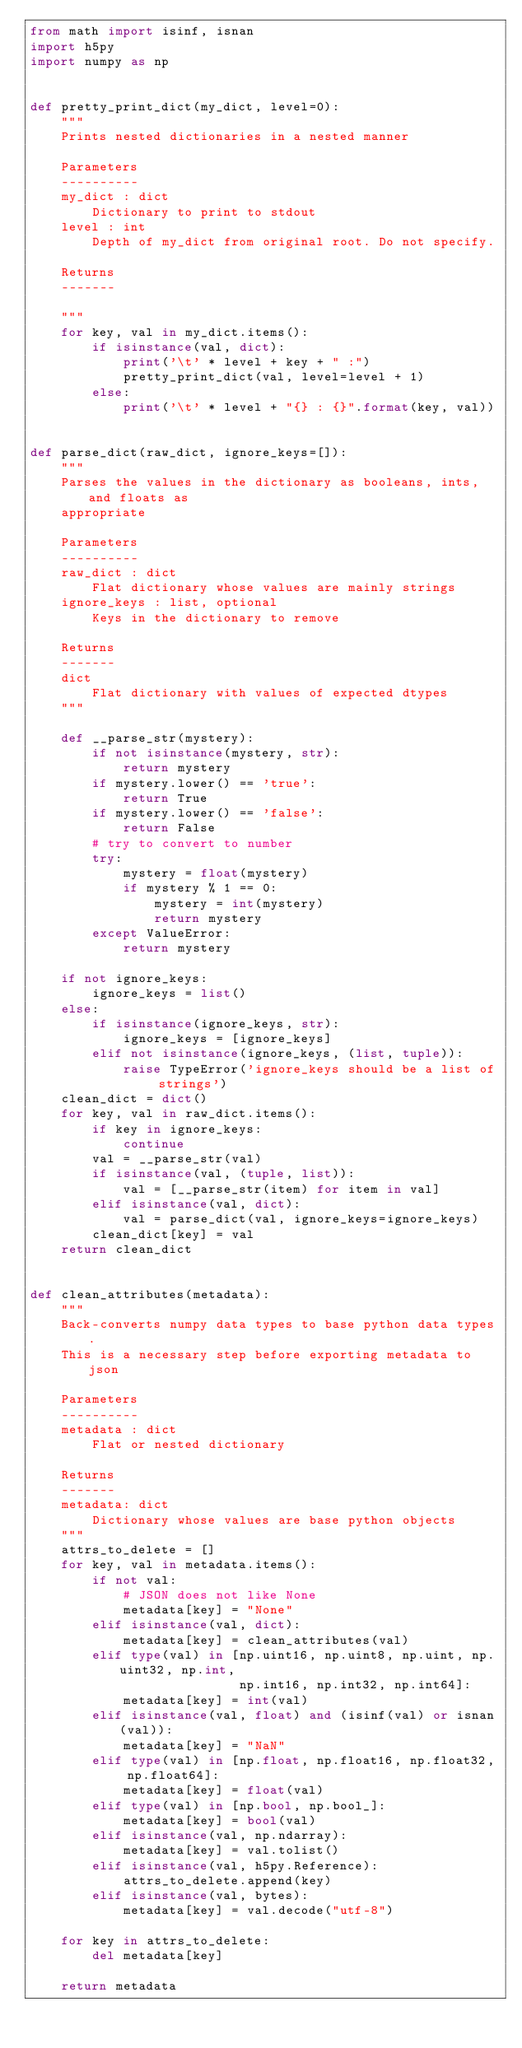<code> <loc_0><loc_0><loc_500><loc_500><_Python_>from math import isinf, isnan
import h5py
import numpy as np


def pretty_print_dict(my_dict, level=0):
    """
    Prints nested dictionaries in a nested manner

    Parameters
    ----------
    my_dict : dict
        Dictionary to print to stdout
    level : int
        Depth of my_dict from original root. Do not specify.

    Returns
    -------

    """
    for key, val in my_dict.items():
        if isinstance(val, dict):
            print('\t' * level + key + " :")
            pretty_print_dict(val, level=level + 1)
        else:
            print('\t' * level + "{} : {}".format(key, val))


def parse_dict(raw_dict, ignore_keys=[]):
    """
    Parses the values in the dictionary as booleans, ints, and floats as
    appropriate

    Parameters
    ----------
    raw_dict : dict
        Flat dictionary whose values are mainly strings
    ignore_keys : list, optional
        Keys in the dictionary to remove

    Returns
    -------
    dict
        Flat dictionary with values of expected dtypes
    """

    def __parse_str(mystery):
        if not isinstance(mystery, str):
            return mystery
        if mystery.lower() == 'true':
            return True
        if mystery.lower() == 'false':
            return False
        # try to convert to number
        try:
            mystery = float(mystery)
            if mystery % 1 == 0:
                mystery = int(mystery)
                return mystery
        except ValueError:
            return mystery

    if not ignore_keys:
        ignore_keys = list()
    else:
        if isinstance(ignore_keys, str):
            ignore_keys = [ignore_keys]
        elif not isinstance(ignore_keys, (list, tuple)):
            raise TypeError('ignore_keys should be a list of strings')
    clean_dict = dict()
    for key, val in raw_dict.items():
        if key in ignore_keys:
            continue
        val = __parse_str(val)
        if isinstance(val, (tuple, list)):
            val = [__parse_str(item) for item in val]
        elif isinstance(val, dict):
            val = parse_dict(val, ignore_keys=ignore_keys)
        clean_dict[key] = val
    return clean_dict


def clean_attributes(metadata):
    """
    Back-converts numpy data types to base python data types.
    This is a necessary step before exporting metadata to json

    Parameters
    ----------
    metadata : dict
        Flat or nested dictionary

    Returns
    -------
    metadata: dict
        Dictionary whose values are base python objects
    """
    attrs_to_delete = []
    for key, val in metadata.items():
        if not val:
            # JSON does not like None
            metadata[key] = "None"
        elif isinstance(val, dict):
            metadata[key] = clean_attributes(val)
        elif type(val) in [np.uint16, np.uint8, np.uint, np.uint32, np.int,
                           np.int16, np.int32, np.int64]:
            metadata[key] = int(val)
        elif isinstance(val, float) and (isinf(val) or isnan(val)):
            metadata[key] = "NaN"
        elif type(val) in [np.float, np.float16, np.float32, np.float64]:
            metadata[key] = float(val)
        elif type(val) in [np.bool, np.bool_]:
            metadata[key] = bool(val)
        elif isinstance(val, np.ndarray):
            metadata[key] = val.tolist()
        elif isinstance(val, h5py.Reference):
            attrs_to_delete.append(key)
        elif isinstance(val, bytes):
            metadata[key] = val.decode("utf-8")

    for key in attrs_to_delete:
        del metadata[key]

    return metadata
</code> 